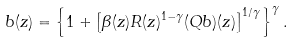Convert formula to latex. <formula><loc_0><loc_0><loc_500><loc_500>b ( z ) = \left \{ 1 + \left [ \beta ( z ) R ( z ) ^ { 1 - \gamma } ( Q b ) ( z ) \right ] ^ { 1 / \gamma } \right \} ^ { \gamma } .</formula> 